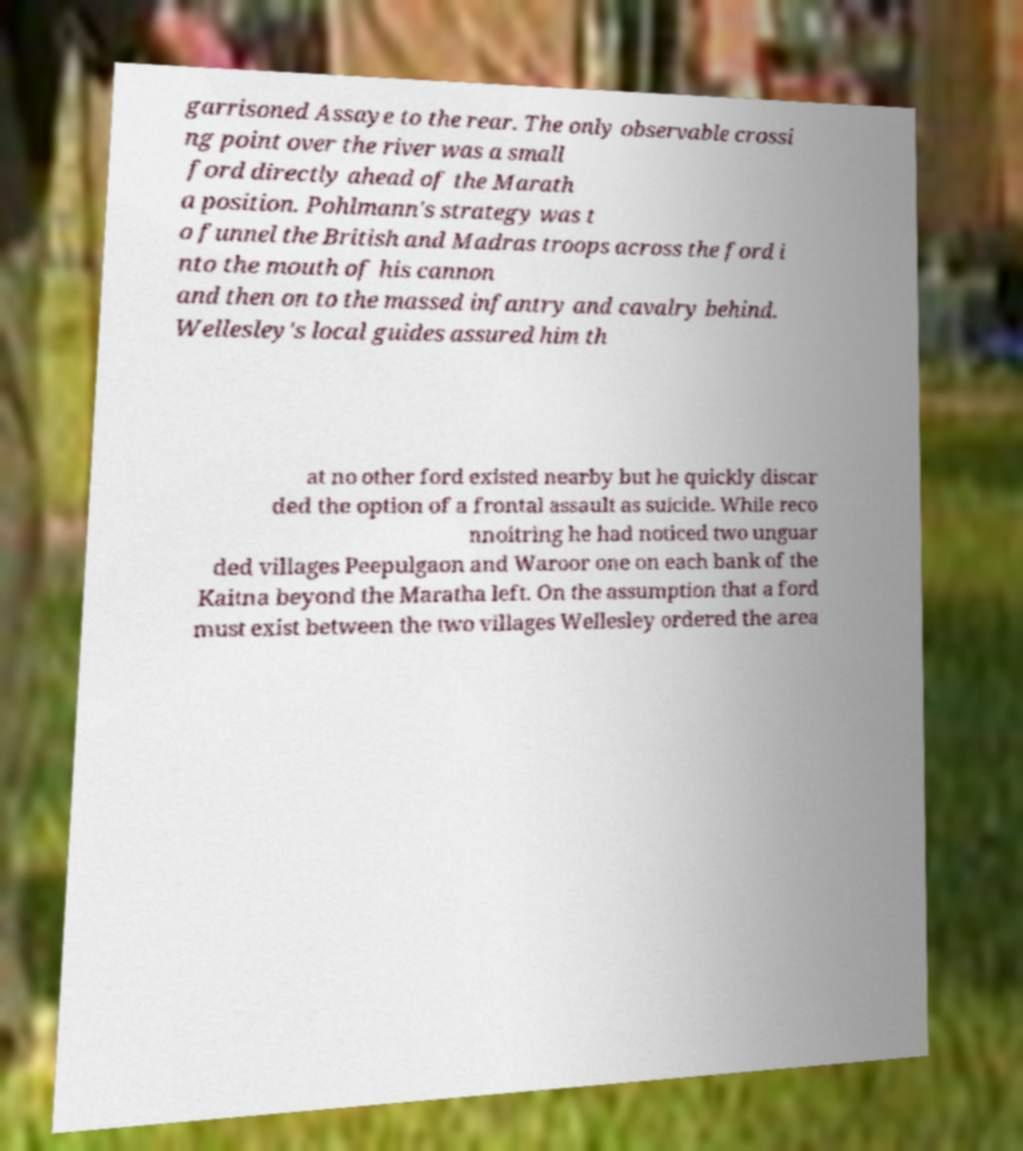Please identify and transcribe the text found in this image. garrisoned Assaye to the rear. The only observable crossi ng point over the river was a small ford directly ahead of the Marath a position. Pohlmann's strategy was t o funnel the British and Madras troops across the ford i nto the mouth of his cannon and then on to the massed infantry and cavalry behind. Wellesley's local guides assured him th at no other ford existed nearby but he quickly discar ded the option of a frontal assault as suicide. While reco nnoitring he had noticed two unguar ded villages Peepulgaon and Waroor one on each bank of the Kaitna beyond the Maratha left. On the assumption that a ford must exist between the two villages Wellesley ordered the area 